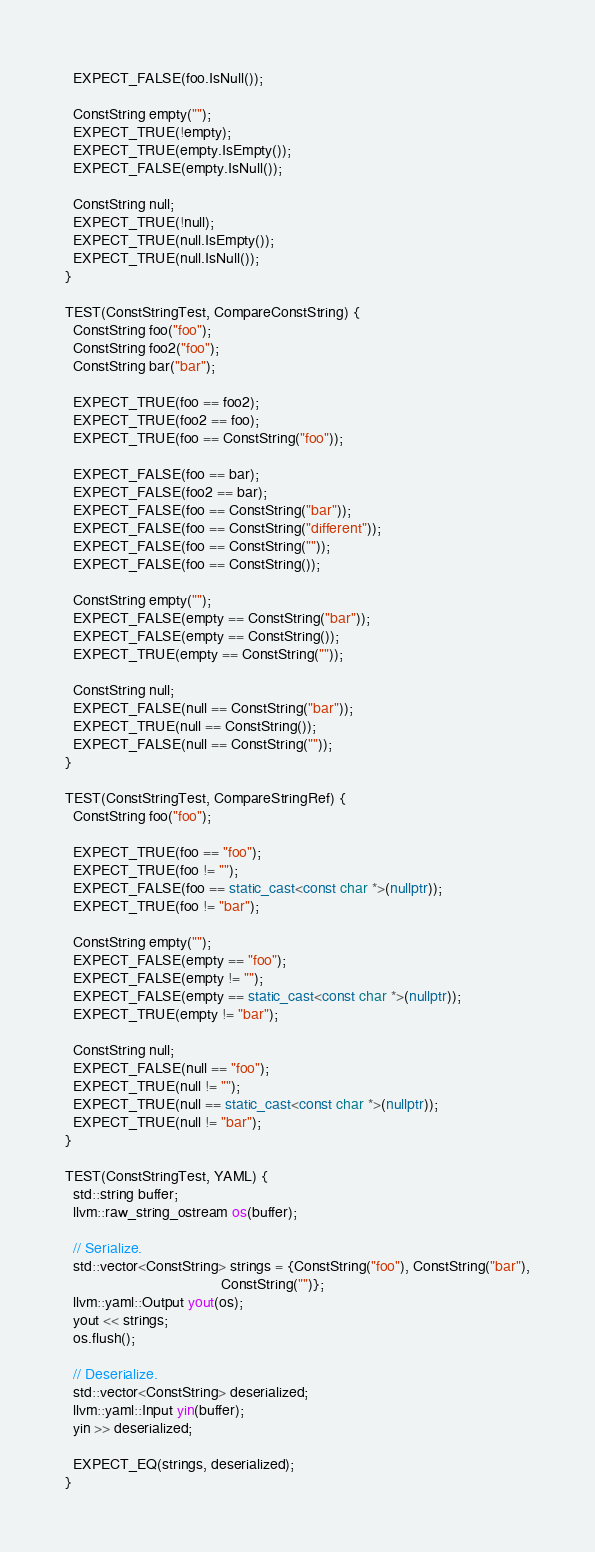Convert code to text. <code><loc_0><loc_0><loc_500><loc_500><_C++_>  EXPECT_FALSE(foo.IsNull());

  ConstString empty("");
  EXPECT_TRUE(!empty);
  EXPECT_TRUE(empty.IsEmpty());
  EXPECT_FALSE(empty.IsNull());

  ConstString null;
  EXPECT_TRUE(!null);
  EXPECT_TRUE(null.IsEmpty());
  EXPECT_TRUE(null.IsNull());
}

TEST(ConstStringTest, CompareConstString) {
  ConstString foo("foo");
  ConstString foo2("foo");
  ConstString bar("bar");

  EXPECT_TRUE(foo == foo2);
  EXPECT_TRUE(foo2 == foo);
  EXPECT_TRUE(foo == ConstString("foo"));

  EXPECT_FALSE(foo == bar);
  EXPECT_FALSE(foo2 == bar);
  EXPECT_FALSE(foo == ConstString("bar"));
  EXPECT_FALSE(foo == ConstString("different"));
  EXPECT_FALSE(foo == ConstString(""));
  EXPECT_FALSE(foo == ConstString());

  ConstString empty("");
  EXPECT_FALSE(empty == ConstString("bar"));
  EXPECT_FALSE(empty == ConstString());
  EXPECT_TRUE(empty == ConstString(""));

  ConstString null;
  EXPECT_FALSE(null == ConstString("bar"));
  EXPECT_TRUE(null == ConstString());
  EXPECT_FALSE(null == ConstString(""));
}

TEST(ConstStringTest, CompareStringRef) {
  ConstString foo("foo");

  EXPECT_TRUE(foo == "foo");
  EXPECT_TRUE(foo != "");
  EXPECT_FALSE(foo == static_cast<const char *>(nullptr));
  EXPECT_TRUE(foo != "bar");

  ConstString empty("");
  EXPECT_FALSE(empty == "foo");
  EXPECT_FALSE(empty != "");
  EXPECT_FALSE(empty == static_cast<const char *>(nullptr));
  EXPECT_TRUE(empty != "bar");

  ConstString null;
  EXPECT_FALSE(null == "foo");
  EXPECT_TRUE(null != "");
  EXPECT_TRUE(null == static_cast<const char *>(nullptr));
  EXPECT_TRUE(null != "bar");
}

TEST(ConstStringTest, YAML) {
  std::string buffer;
  llvm::raw_string_ostream os(buffer);

  // Serialize.
  std::vector<ConstString> strings = {ConstString("foo"), ConstString("bar"),
                                      ConstString("")};
  llvm::yaml::Output yout(os);
  yout << strings;
  os.flush();

  // Deserialize.
  std::vector<ConstString> deserialized;
  llvm::yaml::Input yin(buffer);
  yin >> deserialized;

  EXPECT_EQ(strings, deserialized);
}
</code> 